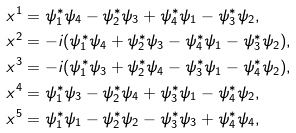<formula> <loc_0><loc_0><loc_500><loc_500>& x ^ { 1 } = \psi _ { 1 } ^ { * } \psi _ { 4 } - \psi ^ { * } _ { 2 } \psi _ { 3 } + \psi _ { 4 } ^ { * } \psi _ { 1 } - \psi _ { 3 } ^ { * } \psi _ { 2 } , \\ & x ^ { 2 } = - i ( \psi _ { 1 } ^ { * } \psi _ { 4 } + \psi ^ { * } _ { 2 } \psi _ { 3 } - \psi _ { 4 } ^ { * } \psi _ { 1 } - \psi _ { 3 } ^ { * } \psi _ { 2 } ) , \\ & x ^ { 3 } = - i ( \psi _ { 1 } ^ { * } \psi _ { 3 } + \psi ^ { * } _ { 2 } \psi _ { 4 } - \psi _ { 3 } ^ { * } \psi _ { 1 } - \psi _ { 4 } ^ { * } \psi _ { 2 } ) , \\ & x ^ { 4 } = \psi _ { 1 } ^ { * } \psi _ { 3 } - \psi ^ { * } _ { 2 } \psi _ { 4 } + \psi _ { 3 } ^ { * } \psi _ { 1 } - \psi _ { 4 } ^ { * } \psi _ { 2 } , \\ & x ^ { 5 } = \psi _ { 1 } ^ { * } \psi _ { 1 } - \psi ^ { * } _ { 2 } \psi _ { 2 } - \psi _ { 3 } ^ { * } \psi _ { 3 } + \psi _ { 4 } ^ { * } \psi _ { 4 } ,</formula> 